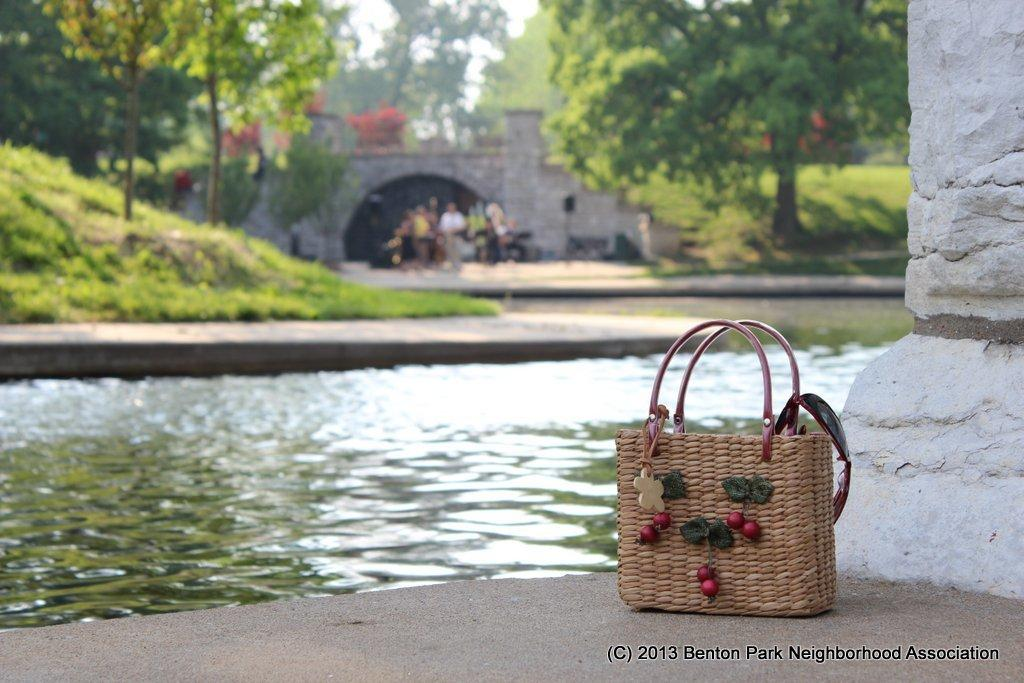What is placed on a surface in the image? There is a basket placed on a surface in the image. What architectural feature can be seen in the image? There is a pillar in the image. What natural element is visible in the image? There is water visible in the image. What type of vegetation is present in the image? There is grass and a group of trees in the image. What man-made structure is visible in the image? There is a building in the image. What other object can be seen in the image? There is a pole in the image. What can be seen in the image that indicates the presence of people? There is a group of people standing in the image. What is visible in the background of the image? The sky is visible in the image. What type of instrument is being played by the nation in the image? There is no nation or instrument present in the image. What is the fifth element visible in the image? The facts provided do not indicate that there are exactly five elements visible in the image. 